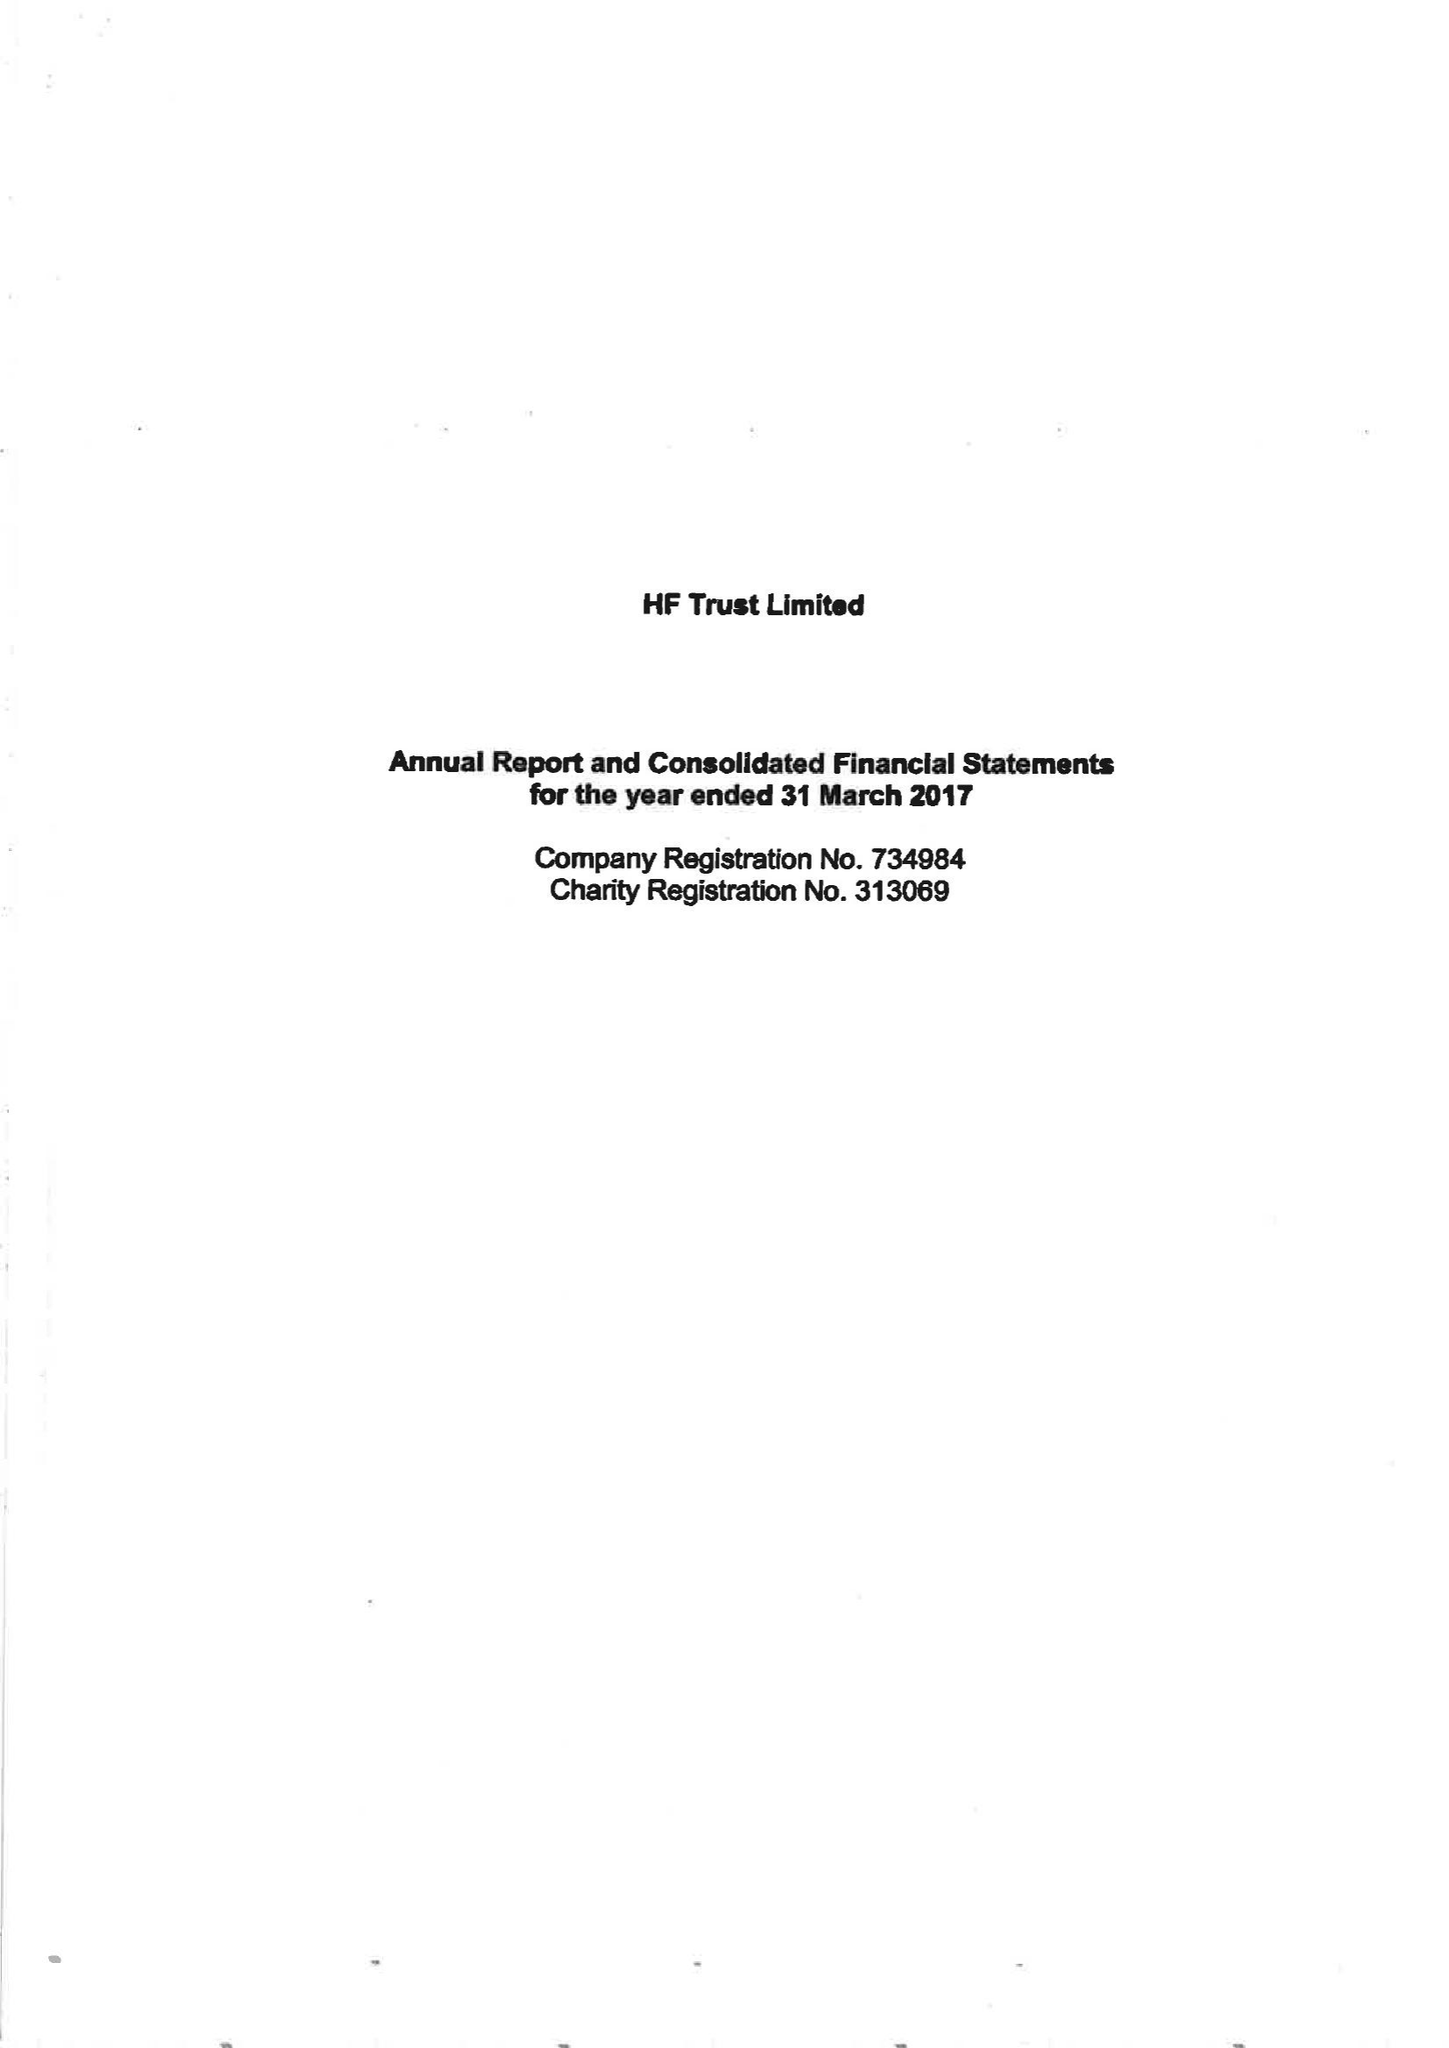What is the value for the report_date?
Answer the question using a single word or phrase. 2017-03-31 